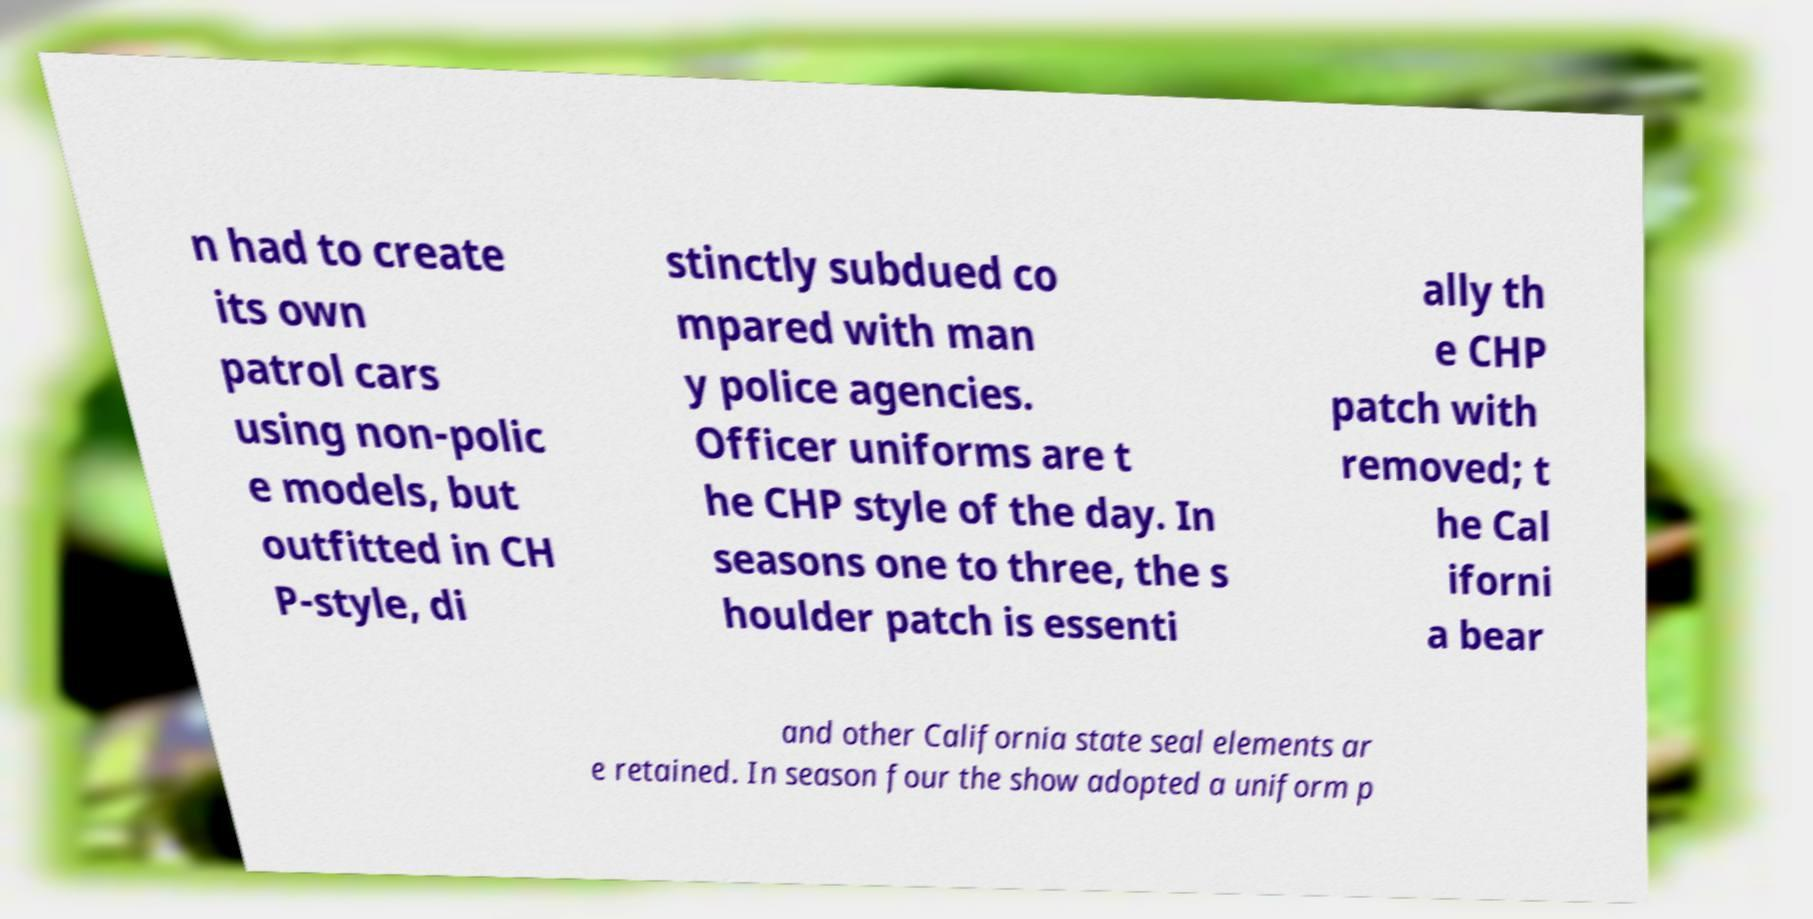What messages or text are displayed in this image? I need them in a readable, typed format. n had to create its own patrol cars using non-polic e models, but outfitted in CH P-style, di stinctly subdued co mpared with man y police agencies. Officer uniforms are t he CHP style of the day. In seasons one to three, the s houlder patch is essenti ally th e CHP patch with removed; t he Cal iforni a bear and other California state seal elements ar e retained. In season four the show adopted a uniform p 